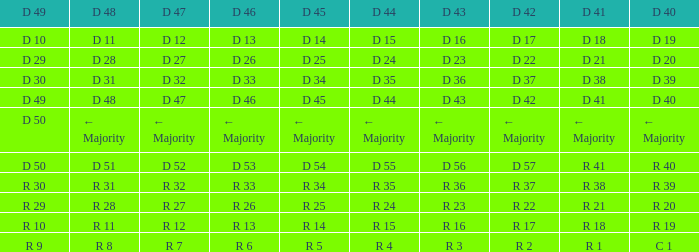Can you parse all the data within this table? {'header': ['D 49', 'D 48', 'D 47', 'D 46', 'D 45', 'D 44', 'D 43', 'D 42', 'D 41', 'D 40'], 'rows': [['D 10', 'D 11', 'D 12', 'D 13', 'D 14', 'D 15', 'D 16', 'D 17', 'D 18', 'D 19'], ['D 29', 'D 28', 'D 27', 'D 26', 'D 25', 'D 24', 'D 23', 'D 22', 'D 21', 'D 20'], ['D 30', 'D 31', 'D 32', 'D 33', 'D 34', 'D 35', 'D 36', 'D 37', 'D 38', 'D 39'], ['D 49', 'D 48', 'D 47', 'D 46', 'D 45', 'D 44', 'D 43', 'D 42', 'D 41', 'D 40'], ['D 50', '← Majority', '← Majority', '← Majority', '← Majority', '← Majority', '← Majority', '← Majority', '← Majority', '← Majority'], ['D 50', 'D 51', 'D 52', 'D 53', 'D 54', 'D 55', 'D 56', 'D 57', 'R 41', 'R 40'], ['R 30', 'R 31', 'R 32', 'R 33', 'R 34', 'R 35', 'R 36', 'R 37', 'R 38', 'R 39'], ['R 29', 'R 28', 'R 27', 'R 26', 'R 25', 'R 24', 'R 23', 'R 22', 'R 21', 'R 20'], ['R 10', 'R 11', 'R 12', 'R 13', 'R 14', 'R 15', 'R 16', 'R 17', 'R 18', 'R 19'], ['R 9', 'R 8', 'R 7', 'R 6', 'R 5', 'R 4', 'R 3', 'R 2', 'R 1', 'C 1']]} I want the D 46 for D 45 of r 5 R 6. 